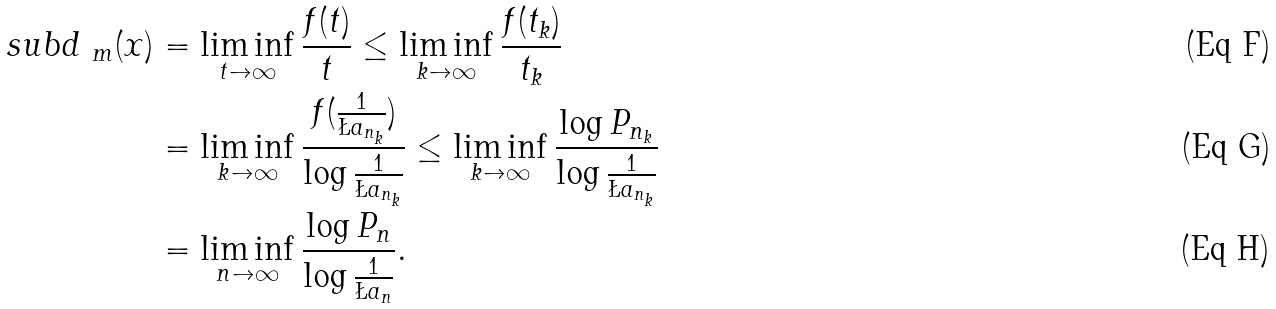Convert formula to latex. <formula><loc_0><loc_0><loc_500><loc_500>\ s u b d _ { \ m } ( x ) & = \liminf _ { t \to \infty } \frac { f ( t ) } { t } \leq \liminf _ { k \to \infty } \frac { f ( t _ { k } ) } { t _ { k } } \\ & = \liminf _ { k \to \infty } \frac { f ( \frac { 1 } { \L a _ { n _ { k } } } ) } { \log \frac { 1 } { \L a _ { n _ { k } } } } \leq \liminf _ { k \to \infty } \frac { \log P _ { n _ { k } } } { \log \frac { 1 } { \L a _ { n _ { k } } } } \\ & = \liminf _ { n \to \infty } \frac { \log P _ { n } } { \log \frac { 1 } { \L a _ { n } } } .</formula> 